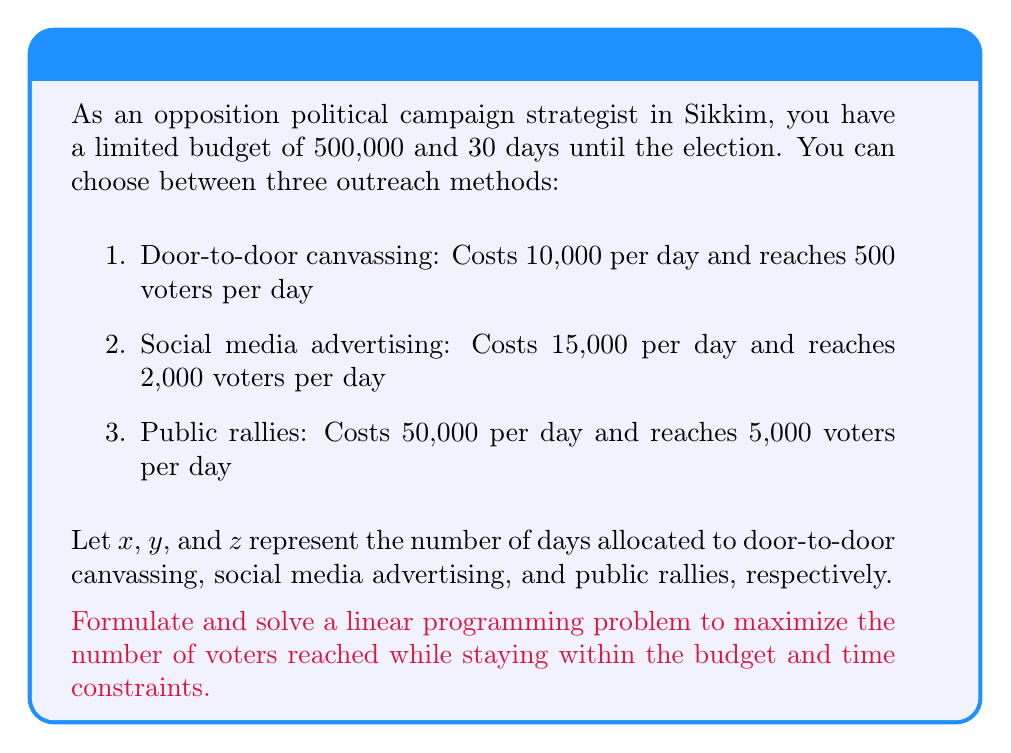Teach me how to tackle this problem. To solve this linear programming problem, we need to:

1. Define the objective function
2. Identify the constraints
3. Set up the linear programming model
4. Solve the model using the simplex method or graphical method

Step 1: Define the objective function

The objective is to maximize the number of voters reached:

$$\text{Maximize } f(x,y,z) = 500x + 2000y + 5000z$$

Step 2: Identify the constraints

Budget constraint: $10000x + 15000y + 50000z \leq 500000$
Time constraint: $x + y + z \leq 30$
Non-negativity constraints: $x \geq 0$, $y \geq 0$, $z \geq 0$

Step 3: Set up the linear programming model

$$\begin{align*}
\text{Maximize } &f(x,y,z) = 500x + 2000y + 5000z \\
\text{Subject to: } &10000x + 15000y + 50000z \leq 500000 \\
&x + y + z \leq 30 \\
&x, y, z \geq 0
\end{align*}$$

Step 4: Solve the model

We can solve this using the simplex method or graphical method. For simplicity, we'll use the graphical method and consider the two-variable case (x and y) while keeping z = 0.

Simplifying the constraints:
1. $2x + 3y \leq 100$ (budget constraint divided by 5000)
2. $x + y \leq 30$ (time constraint)

Plotting these constraints and the objective function lines, we find that the optimal solution occurs at the intersection of the two constraint lines:

Solving the system of equations:
$$\begin{align*}
2x + 3y &= 100 \\
x + y &= 30
\end{align*}$$

We get: $x = 10$ and $y = 20$

Therefore, the optimal solution is:
- 10 days of door-to-door canvassing
- 20 days of social media advertising
- 0 days of public rallies

The maximum number of voters reached is:

$f(10, 20, 0) = 500(10) + 2000(20) + 5000(0) = 45,000$ voters
Answer: The optimal strategy is to allocate 10 days to door-to-door canvassing and 20 days to social media advertising, reaching a maximum of 45,000 voters. 